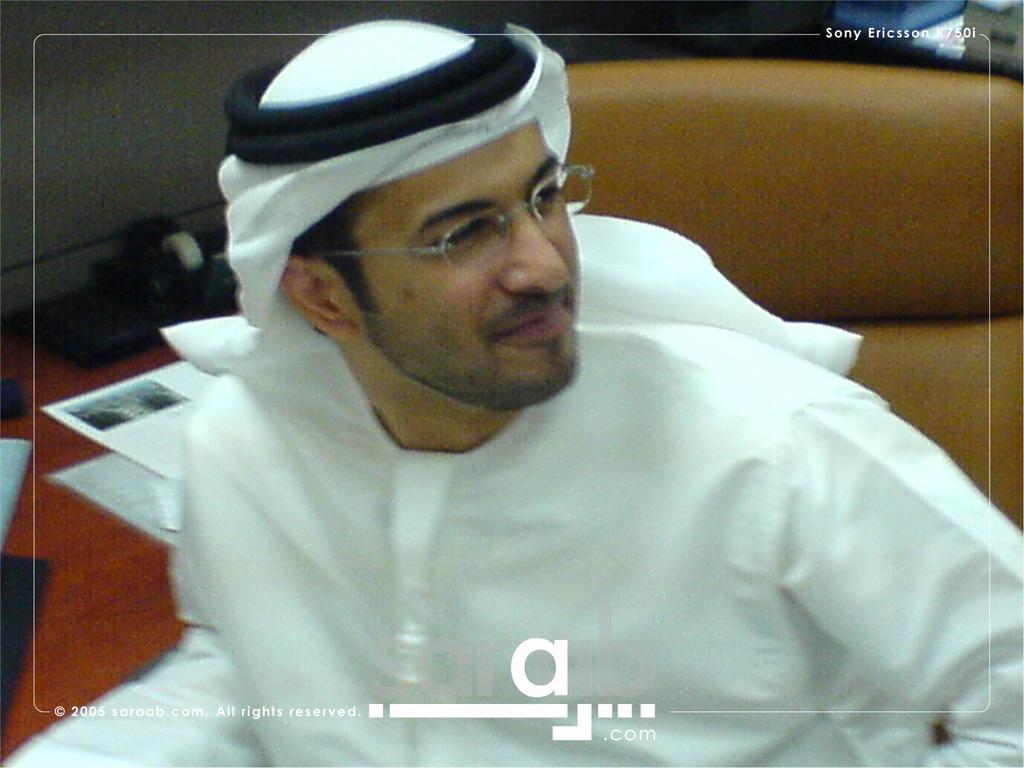Describe this image in one or two sentences. In this image I can see a person wearing white color dress. Back I can see papers on the brown color table. 